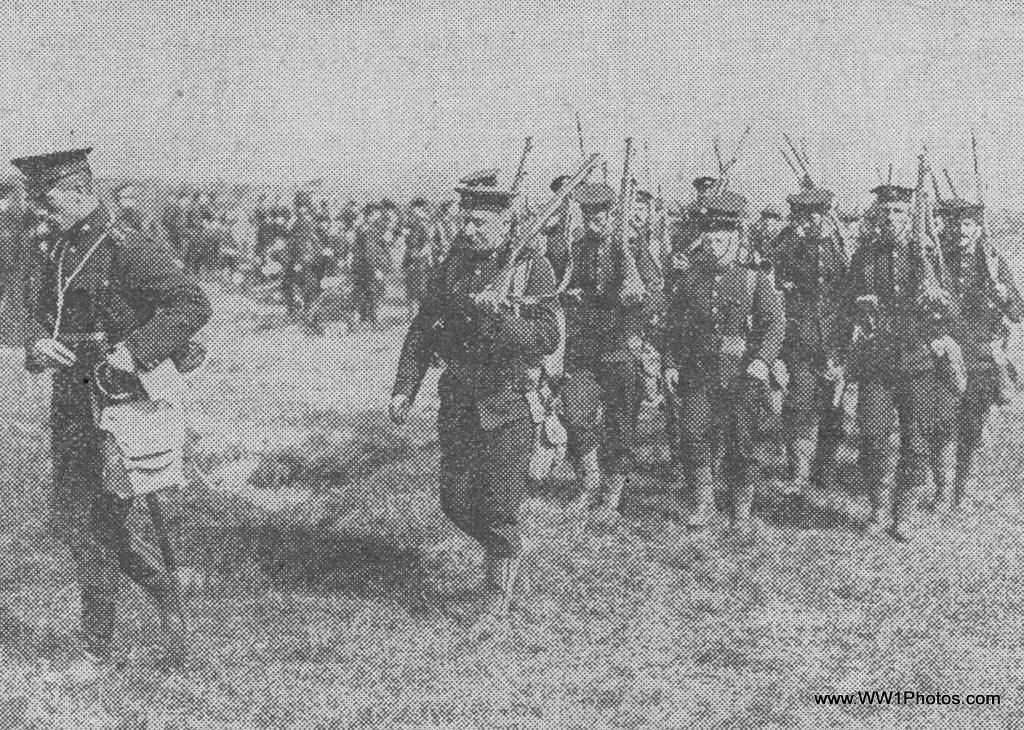Who or what is present in the image? There are people in the image. What are the people holding in the image? The people are holding guns. What type of terrain can be seen in the image? The people are walking on the grass. What type of canvas is being used to transport the company's goods in the image? There is no canvas or company present in the image; it features people holding guns and walking on the grass. 